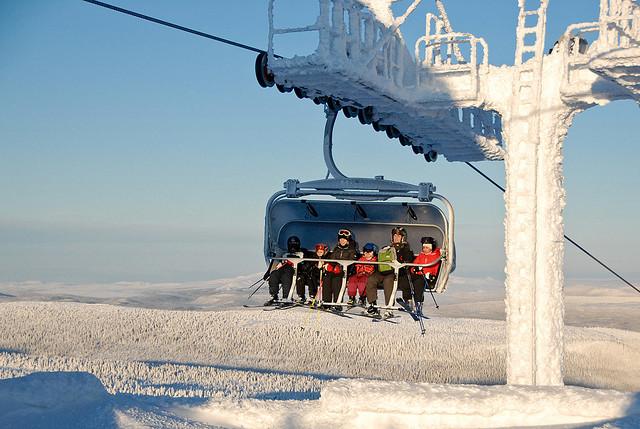What is the pole covered in?
Keep it brief. Ice. How many people are on the lift?
Short answer required. 6. How many people are on the ski lift?
Short answer required. 6. What are the people about to do?
Write a very short answer. Ski. 